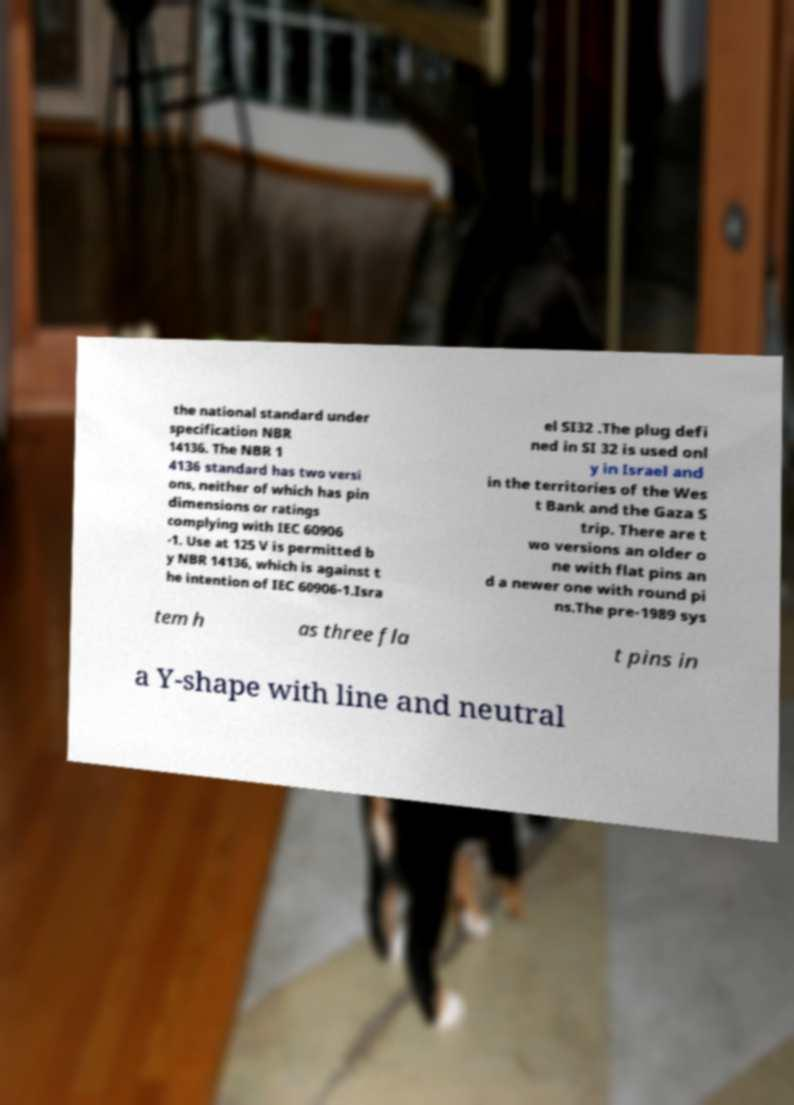I need the written content from this picture converted into text. Can you do that? the national standard under specification NBR 14136. The NBR 1 4136 standard has two versi ons, neither of which has pin dimensions or ratings complying with IEC 60906 -1. Use at 125 V is permitted b y NBR 14136, which is against t he intention of IEC 60906-1.Isra el SI32 .The plug defi ned in SI 32 is used onl y in Israel and in the territories of the Wes t Bank and the Gaza S trip. There are t wo versions an older o ne with flat pins an d a newer one with round pi ns.The pre-1989 sys tem h as three fla t pins in a Y-shape with line and neutral 